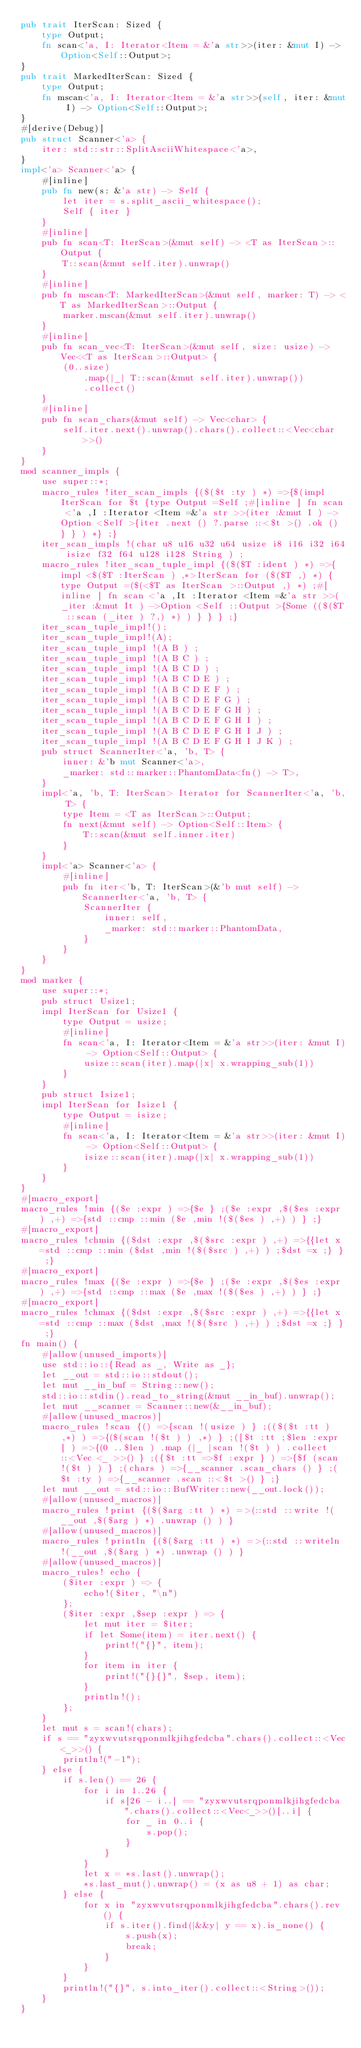Convert code to text. <code><loc_0><loc_0><loc_500><loc_500><_Rust_>pub trait IterScan: Sized {
    type Output;
    fn scan<'a, I: Iterator<Item = &'a str>>(iter: &mut I) -> Option<Self::Output>;
}
pub trait MarkedIterScan: Sized {
    type Output;
    fn mscan<'a, I: Iterator<Item = &'a str>>(self, iter: &mut I) -> Option<Self::Output>;
}
#[derive(Debug)]
pub struct Scanner<'a> {
    iter: std::str::SplitAsciiWhitespace<'a>,
}
impl<'a> Scanner<'a> {
    #[inline]
    pub fn new(s: &'a str) -> Self {
        let iter = s.split_ascii_whitespace();
        Self { iter }
    }
    #[inline]
    pub fn scan<T: IterScan>(&mut self) -> <T as IterScan>::Output {
        T::scan(&mut self.iter).unwrap()
    }
    #[inline]
    pub fn mscan<T: MarkedIterScan>(&mut self, marker: T) -> <T as MarkedIterScan>::Output {
        marker.mscan(&mut self.iter).unwrap()
    }
    #[inline]
    pub fn scan_vec<T: IterScan>(&mut self, size: usize) -> Vec<<T as IterScan>::Output> {
        (0..size)
            .map(|_| T::scan(&mut self.iter).unwrap())
            .collect()
    }
    #[inline]
    pub fn scan_chars(&mut self) -> Vec<char> {
        self.iter.next().unwrap().chars().collect::<Vec<char>>()
    }
}
mod scanner_impls {
    use super::*;
    macro_rules !iter_scan_impls {($($t :ty ) *) =>{$(impl IterScan for $t {type Output =Self ;#[inline ] fn scan <'a ,I :Iterator <Item =&'a str >>(iter :&mut I ) ->Option <Self >{iter .next () ?.parse ::<$t >() .ok () } } ) *} ;}
    iter_scan_impls !(char u8 u16 u32 u64 usize i8 i16 i32 i64 isize f32 f64 u128 i128 String ) ;
    macro_rules !iter_scan_tuple_impl {($($T :ident ) *) =>{impl <$($T :IterScan ) ,*>IterScan for ($($T ,) *) {type Output =($(<$T as IterScan >::Output ,) *) ;#[inline ] fn scan <'a ,It :Iterator <Item =&'a str >>(_iter :&mut It ) ->Option <Self ::Output >{Some (($($T ::scan (_iter ) ?,) *) ) } } } ;}
    iter_scan_tuple_impl!();
    iter_scan_tuple_impl!(A);
    iter_scan_tuple_impl !(A B ) ;
    iter_scan_tuple_impl !(A B C ) ;
    iter_scan_tuple_impl !(A B C D ) ;
    iter_scan_tuple_impl !(A B C D E ) ;
    iter_scan_tuple_impl !(A B C D E F ) ;
    iter_scan_tuple_impl !(A B C D E F G ) ;
    iter_scan_tuple_impl !(A B C D E F G H ) ;
    iter_scan_tuple_impl !(A B C D E F G H I ) ;
    iter_scan_tuple_impl !(A B C D E F G H I J ) ;
    iter_scan_tuple_impl !(A B C D E F G H I J K ) ;
    pub struct ScannerIter<'a, 'b, T> {
        inner: &'b mut Scanner<'a>,
        _marker: std::marker::PhantomData<fn() -> T>,
    }
    impl<'a, 'b, T: IterScan> Iterator for ScannerIter<'a, 'b, T> {
        type Item = <T as IterScan>::Output;
        fn next(&mut self) -> Option<Self::Item> {
            T::scan(&mut self.inner.iter)
        }
    }
    impl<'a> Scanner<'a> {
        #[inline]
        pub fn iter<'b, T: IterScan>(&'b mut self) -> ScannerIter<'a, 'b, T> {
            ScannerIter {
                inner: self,
                _marker: std::marker::PhantomData,
            }
        }
    }
}
mod marker {
    use super::*;
    pub struct Usize1;
    impl IterScan for Usize1 {
        type Output = usize;
        #[inline]
        fn scan<'a, I: Iterator<Item = &'a str>>(iter: &mut I) -> Option<Self::Output> {
            usize::scan(iter).map(|x| x.wrapping_sub(1))
        }
    }
    pub struct Isize1;
    impl IterScan for Isize1 {
        type Output = isize;
        #[inline]
        fn scan<'a, I: Iterator<Item = &'a str>>(iter: &mut I) -> Option<Self::Output> {
            isize::scan(iter).map(|x| x.wrapping_sub(1))
        }
    }
}
#[macro_export]
macro_rules !min {($e :expr ) =>{$e } ;($e :expr ,$($es :expr ) ,+) =>{std ::cmp ::min ($e ,min !($($es ) ,+) ) } ;}
#[macro_export]
macro_rules !chmin {($dst :expr ,$($src :expr ) ,+) =>{{let x =std ::cmp ::min ($dst ,min !($($src ) ,+) ) ;$dst =x ;} } ;}
#[macro_export]
macro_rules !max {($e :expr ) =>{$e } ;($e :expr ,$($es :expr ) ,+) =>{std ::cmp ::max ($e ,max !($($es ) ,+) ) } ;}
#[macro_export]
macro_rules !chmax {($dst :expr ,$($src :expr ) ,+) =>{{let x =std ::cmp ::max ($dst ,max !($($src ) ,+) ) ;$dst =x ;} } ;}
fn main() {
    #[allow(unused_imports)]
    use std::io::{Read as _, Write as _};
    let __out = std::io::stdout();
    let mut __in_buf = String::new();
    std::io::stdin().read_to_string(&mut __in_buf).unwrap();
    let mut __scanner = Scanner::new(&__in_buf);
    #[allow(unused_macros)]
    macro_rules !scan {() =>{scan !(usize ) } ;(($($t :tt ) ,*) ) =>{($(scan !($t ) ) ,*) } ;([$t :tt ;$len :expr ] ) =>{(0 ..$len ) .map (|_ |scan !($t ) ) .collect ::<Vec <_ >>() } ;({$t :tt =>$f :expr } ) =>{$f (scan !($t ) ) } ;(chars ) =>{__scanner .scan_chars () } ;($t :ty ) =>{__scanner .scan ::<$t >() } ;}
    let mut __out = std::io::BufWriter::new(__out.lock());
    #[allow(unused_macros)]
    macro_rules !print {($($arg :tt ) *) =>(::std ::write !(__out ,$($arg ) *) .unwrap () ) }
    #[allow(unused_macros)]
    macro_rules !println {($($arg :tt ) *) =>(::std ::writeln !(__out ,$($arg ) *) .unwrap () ) }
    #[allow(unused_macros)]
    macro_rules! echo {
        ($iter :expr ) => {
            echo!($iter, "\n")
        };
        ($iter :expr ,$sep :expr ) => {
            let mut iter = $iter;
            if let Some(item) = iter.next() {
                print!("{}", item);
            }
            for item in iter {
                print!("{}{}", $sep, item);
            }
            println!();
        };
    }
    let mut s = scan!(chars);
    if s == "zyxwvutsrqponmlkjihgfedcba".chars().collect::<Vec<_>>() {
        println!("-1");
    } else {
        if s.len() == 26 {
            for i in 1..26 {
                if s[26 - i..] == "zyxwvutsrqponmlkjihgfedcba".chars().collect::<Vec<_>>()[..i] {
                    for _ in 0..i {
                        s.pop();
                    }
                }
            }
            let x = *s.last().unwrap();
            *s.last_mut().unwrap() = (x as u8 + 1) as char;
        } else {
            for x in "zyxwvutsrqponmlkjihgfedcba".chars().rev() {
                if s.iter().find(|&&y| y == x).is_none() {
                    s.push(x);
                    break;
                }
            }
        }
        println!("{}", s.into_iter().collect::<String>());
    }
}</code> 